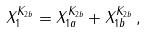Convert formula to latex. <formula><loc_0><loc_0><loc_500><loc_500>X ^ { K _ { 2 b } } _ { 1 } = X ^ { K _ { 2 b } } _ { 1 a } + X ^ { K _ { 2 b } } _ { 1 b } \, ,</formula> 